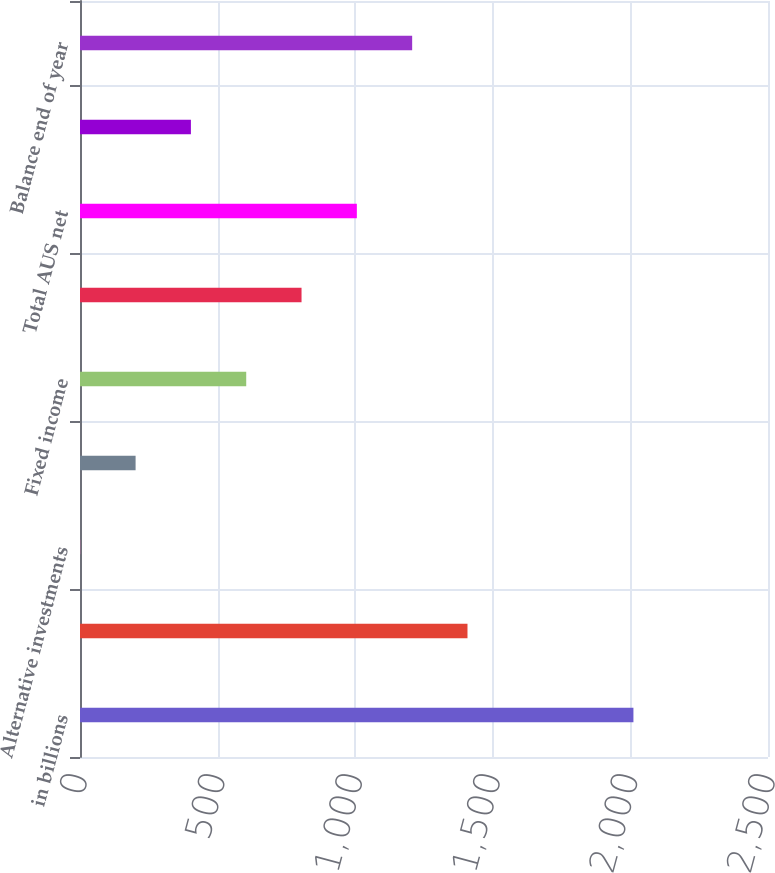<chart> <loc_0><loc_0><loc_500><loc_500><bar_chart><fcel>in billions<fcel>Balance beginning of year<fcel>Alternative investments<fcel>Equity<fcel>Fixed income<fcel>Liquidity products<fcel>Total AUS net<fcel>Net market<fcel>Balance end of year<nl><fcel>2011<fcel>1408<fcel>1<fcel>202<fcel>604<fcel>805<fcel>1006<fcel>403<fcel>1207<nl></chart> 